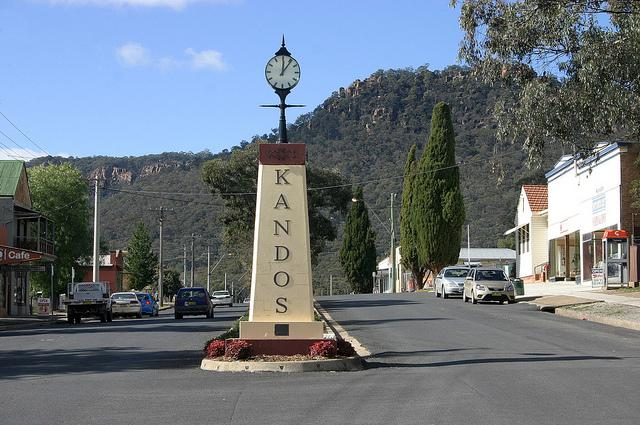What animal is native to this country?

Choices:
A) camel
B) polar bear
C) panda
D) kangaroo kangaroo 